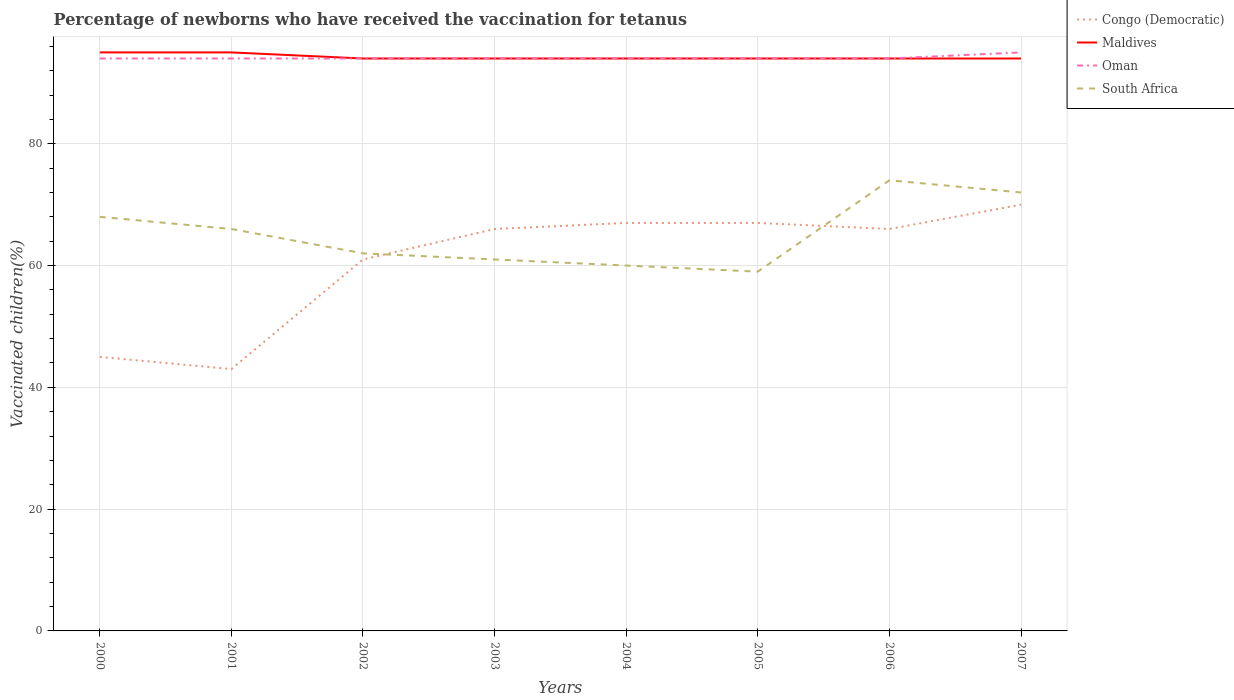How many different coloured lines are there?
Make the answer very short. 4. Is the number of lines equal to the number of legend labels?
Your answer should be compact. Yes. Across all years, what is the maximum percentage of vaccinated children in South Africa?
Ensure brevity in your answer.  59. What is the difference between the highest and the second highest percentage of vaccinated children in Maldives?
Your answer should be very brief. 1. What is the difference between the highest and the lowest percentage of vaccinated children in Oman?
Make the answer very short. 1. Does the graph contain grids?
Ensure brevity in your answer.  Yes. How are the legend labels stacked?
Give a very brief answer. Vertical. What is the title of the graph?
Make the answer very short. Percentage of newborns who have received the vaccination for tetanus. What is the label or title of the Y-axis?
Provide a succinct answer. Vaccinated children(%). What is the Vaccinated children(%) of Maldives in 2000?
Your answer should be compact. 95. What is the Vaccinated children(%) in Oman in 2000?
Your answer should be very brief. 94. What is the Vaccinated children(%) of South Africa in 2000?
Provide a succinct answer. 68. What is the Vaccinated children(%) of Oman in 2001?
Ensure brevity in your answer.  94. What is the Vaccinated children(%) in Congo (Democratic) in 2002?
Your response must be concise. 61. What is the Vaccinated children(%) of Maldives in 2002?
Ensure brevity in your answer.  94. What is the Vaccinated children(%) in Oman in 2002?
Ensure brevity in your answer.  94. What is the Vaccinated children(%) of South Africa in 2002?
Provide a succinct answer. 62. What is the Vaccinated children(%) in Maldives in 2003?
Provide a short and direct response. 94. What is the Vaccinated children(%) of Oman in 2003?
Make the answer very short. 94. What is the Vaccinated children(%) of Congo (Democratic) in 2004?
Provide a short and direct response. 67. What is the Vaccinated children(%) in Maldives in 2004?
Offer a very short reply. 94. What is the Vaccinated children(%) of Oman in 2004?
Offer a terse response. 94. What is the Vaccinated children(%) in South Africa in 2004?
Provide a short and direct response. 60. What is the Vaccinated children(%) of Maldives in 2005?
Your answer should be very brief. 94. What is the Vaccinated children(%) of Oman in 2005?
Your response must be concise. 94. What is the Vaccinated children(%) of South Africa in 2005?
Offer a terse response. 59. What is the Vaccinated children(%) in Congo (Democratic) in 2006?
Your response must be concise. 66. What is the Vaccinated children(%) of Maldives in 2006?
Offer a very short reply. 94. What is the Vaccinated children(%) of Oman in 2006?
Provide a short and direct response. 94. What is the Vaccinated children(%) in South Africa in 2006?
Your response must be concise. 74. What is the Vaccinated children(%) of Maldives in 2007?
Your answer should be very brief. 94. What is the Vaccinated children(%) in Oman in 2007?
Offer a terse response. 95. Across all years, what is the maximum Vaccinated children(%) in Maldives?
Offer a very short reply. 95. Across all years, what is the maximum Vaccinated children(%) of Oman?
Your response must be concise. 95. Across all years, what is the minimum Vaccinated children(%) in Congo (Democratic)?
Offer a very short reply. 43. Across all years, what is the minimum Vaccinated children(%) in Maldives?
Your answer should be very brief. 94. Across all years, what is the minimum Vaccinated children(%) of Oman?
Offer a terse response. 94. Across all years, what is the minimum Vaccinated children(%) of South Africa?
Provide a short and direct response. 59. What is the total Vaccinated children(%) in Congo (Democratic) in the graph?
Make the answer very short. 485. What is the total Vaccinated children(%) in Maldives in the graph?
Your answer should be compact. 754. What is the total Vaccinated children(%) of Oman in the graph?
Offer a terse response. 753. What is the total Vaccinated children(%) of South Africa in the graph?
Keep it short and to the point. 522. What is the difference between the Vaccinated children(%) of Maldives in 2000 and that in 2001?
Keep it short and to the point. 0. What is the difference between the Vaccinated children(%) in Congo (Democratic) in 2000 and that in 2002?
Make the answer very short. -16. What is the difference between the Vaccinated children(%) in Oman in 2000 and that in 2002?
Offer a very short reply. 0. What is the difference between the Vaccinated children(%) of Congo (Democratic) in 2000 and that in 2003?
Ensure brevity in your answer.  -21. What is the difference between the Vaccinated children(%) of South Africa in 2000 and that in 2003?
Your answer should be compact. 7. What is the difference between the Vaccinated children(%) in Congo (Democratic) in 2000 and that in 2004?
Provide a succinct answer. -22. What is the difference between the Vaccinated children(%) in Congo (Democratic) in 2000 and that in 2005?
Your answer should be compact. -22. What is the difference between the Vaccinated children(%) of Maldives in 2000 and that in 2005?
Your answer should be compact. 1. What is the difference between the Vaccinated children(%) of South Africa in 2000 and that in 2005?
Offer a terse response. 9. What is the difference between the Vaccinated children(%) of Congo (Democratic) in 2000 and that in 2006?
Offer a terse response. -21. What is the difference between the Vaccinated children(%) of Maldives in 2000 and that in 2006?
Keep it short and to the point. 1. What is the difference between the Vaccinated children(%) in Oman in 2000 and that in 2006?
Ensure brevity in your answer.  0. What is the difference between the Vaccinated children(%) in South Africa in 2000 and that in 2006?
Offer a terse response. -6. What is the difference between the Vaccinated children(%) of Congo (Democratic) in 2001 and that in 2002?
Ensure brevity in your answer.  -18. What is the difference between the Vaccinated children(%) in South Africa in 2001 and that in 2002?
Your response must be concise. 4. What is the difference between the Vaccinated children(%) in Maldives in 2001 and that in 2003?
Offer a terse response. 1. What is the difference between the Vaccinated children(%) of Oman in 2001 and that in 2003?
Your answer should be compact. 0. What is the difference between the Vaccinated children(%) in Congo (Democratic) in 2001 and that in 2004?
Make the answer very short. -24. What is the difference between the Vaccinated children(%) in South Africa in 2001 and that in 2004?
Offer a very short reply. 6. What is the difference between the Vaccinated children(%) in Oman in 2001 and that in 2005?
Give a very brief answer. 0. What is the difference between the Vaccinated children(%) in South Africa in 2001 and that in 2005?
Keep it short and to the point. 7. What is the difference between the Vaccinated children(%) in Oman in 2001 and that in 2006?
Ensure brevity in your answer.  0. What is the difference between the Vaccinated children(%) in Congo (Democratic) in 2001 and that in 2007?
Keep it short and to the point. -27. What is the difference between the Vaccinated children(%) of Maldives in 2001 and that in 2007?
Provide a short and direct response. 1. What is the difference between the Vaccinated children(%) in South Africa in 2001 and that in 2007?
Provide a short and direct response. -6. What is the difference between the Vaccinated children(%) of Congo (Democratic) in 2002 and that in 2004?
Provide a succinct answer. -6. What is the difference between the Vaccinated children(%) of Maldives in 2002 and that in 2004?
Give a very brief answer. 0. What is the difference between the Vaccinated children(%) of Oman in 2002 and that in 2004?
Offer a terse response. 0. What is the difference between the Vaccinated children(%) of South Africa in 2002 and that in 2004?
Make the answer very short. 2. What is the difference between the Vaccinated children(%) of Oman in 2002 and that in 2005?
Your response must be concise. 0. What is the difference between the Vaccinated children(%) of South Africa in 2002 and that in 2006?
Your response must be concise. -12. What is the difference between the Vaccinated children(%) of Maldives in 2002 and that in 2007?
Ensure brevity in your answer.  0. What is the difference between the Vaccinated children(%) of Oman in 2002 and that in 2007?
Provide a succinct answer. -1. What is the difference between the Vaccinated children(%) of South Africa in 2002 and that in 2007?
Provide a succinct answer. -10. What is the difference between the Vaccinated children(%) of Congo (Democratic) in 2003 and that in 2004?
Provide a short and direct response. -1. What is the difference between the Vaccinated children(%) in Maldives in 2003 and that in 2004?
Offer a terse response. 0. What is the difference between the Vaccinated children(%) of Oman in 2003 and that in 2004?
Provide a succinct answer. 0. What is the difference between the Vaccinated children(%) of South Africa in 2003 and that in 2004?
Offer a terse response. 1. What is the difference between the Vaccinated children(%) of Congo (Democratic) in 2003 and that in 2007?
Give a very brief answer. -4. What is the difference between the Vaccinated children(%) in Oman in 2003 and that in 2007?
Your response must be concise. -1. What is the difference between the Vaccinated children(%) of South Africa in 2003 and that in 2007?
Ensure brevity in your answer.  -11. What is the difference between the Vaccinated children(%) of Oman in 2004 and that in 2005?
Your answer should be compact. 0. What is the difference between the Vaccinated children(%) of South Africa in 2004 and that in 2006?
Provide a short and direct response. -14. What is the difference between the Vaccinated children(%) in Congo (Democratic) in 2004 and that in 2007?
Offer a very short reply. -3. What is the difference between the Vaccinated children(%) of Maldives in 2004 and that in 2007?
Offer a very short reply. 0. What is the difference between the Vaccinated children(%) in Oman in 2004 and that in 2007?
Ensure brevity in your answer.  -1. What is the difference between the Vaccinated children(%) of Congo (Democratic) in 2005 and that in 2006?
Make the answer very short. 1. What is the difference between the Vaccinated children(%) in Maldives in 2005 and that in 2006?
Your answer should be very brief. 0. What is the difference between the Vaccinated children(%) of Congo (Democratic) in 2005 and that in 2007?
Give a very brief answer. -3. What is the difference between the Vaccinated children(%) of Maldives in 2005 and that in 2007?
Provide a succinct answer. 0. What is the difference between the Vaccinated children(%) of Oman in 2005 and that in 2007?
Ensure brevity in your answer.  -1. What is the difference between the Vaccinated children(%) of Maldives in 2006 and that in 2007?
Offer a very short reply. 0. What is the difference between the Vaccinated children(%) in Oman in 2006 and that in 2007?
Provide a short and direct response. -1. What is the difference between the Vaccinated children(%) of South Africa in 2006 and that in 2007?
Provide a succinct answer. 2. What is the difference between the Vaccinated children(%) in Congo (Democratic) in 2000 and the Vaccinated children(%) in Oman in 2001?
Your answer should be compact. -49. What is the difference between the Vaccinated children(%) in Maldives in 2000 and the Vaccinated children(%) in Oman in 2001?
Keep it short and to the point. 1. What is the difference between the Vaccinated children(%) of Congo (Democratic) in 2000 and the Vaccinated children(%) of Maldives in 2002?
Offer a very short reply. -49. What is the difference between the Vaccinated children(%) of Congo (Democratic) in 2000 and the Vaccinated children(%) of Oman in 2002?
Provide a short and direct response. -49. What is the difference between the Vaccinated children(%) in Maldives in 2000 and the Vaccinated children(%) in Oman in 2002?
Your response must be concise. 1. What is the difference between the Vaccinated children(%) of Congo (Democratic) in 2000 and the Vaccinated children(%) of Maldives in 2003?
Offer a terse response. -49. What is the difference between the Vaccinated children(%) in Congo (Democratic) in 2000 and the Vaccinated children(%) in Oman in 2003?
Provide a short and direct response. -49. What is the difference between the Vaccinated children(%) of Congo (Democratic) in 2000 and the Vaccinated children(%) of South Africa in 2003?
Offer a very short reply. -16. What is the difference between the Vaccinated children(%) in Maldives in 2000 and the Vaccinated children(%) in Oman in 2003?
Ensure brevity in your answer.  1. What is the difference between the Vaccinated children(%) of Maldives in 2000 and the Vaccinated children(%) of South Africa in 2003?
Make the answer very short. 34. What is the difference between the Vaccinated children(%) of Congo (Democratic) in 2000 and the Vaccinated children(%) of Maldives in 2004?
Keep it short and to the point. -49. What is the difference between the Vaccinated children(%) in Congo (Democratic) in 2000 and the Vaccinated children(%) in Oman in 2004?
Keep it short and to the point. -49. What is the difference between the Vaccinated children(%) of Maldives in 2000 and the Vaccinated children(%) of Oman in 2004?
Offer a very short reply. 1. What is the difference between the Vaccinated children(%) of Maldives in 2000 and the Vaccinated children(%) of South Africa in 2004?
Provide a succinct answer. 35. What is the difference between the Vaccinated children(%) of Oman in 2000 and the Vaccinated children(%) of South Africa in 2004?
Your answer should be compact. 34. What is the difference between the Vaccinated children(%) of Congo (Democratic) in 2000 and the Vaccinated children(%) of Maldives in 2005?
Offer a very short reply. -49. What is the difference between the Vaccinated children(%) in Congo (Democratic) in 2000 and the Vaccinated children(%) in Oman in 2005?
Your answer should be compact. -49. What is the difference between the Vaccinated children(%) in Congo (Democratic) in 2000 and the Vaccinated children(%) in South Africa in 2005?
Your answer should be very brief. -14. What is the difference between the Vaccinated children(%) in Maldives in 2000 and the Vaccinated children(%) in South Africa in 2005?
Provide a short and direct response. 36. What is the difference between the Vaccinated children(%) of Oman in 2000 and the Vaccinated children(%) of South Africa in 2005?
Offer a terse response. 35. What is the difference between the Vaccinated children(%) of Congo (Democratic) in 2000 and the Vaccinated children(%) of Maldives in 2006?
Make the answer very short. -49. What is the difference between the Vaccinated children(%) of Congo (Democratic) in 2000 and the Vaccinated children(%) of Oman in 2006?
Provide a short and direct response. -49. What is the difference between the Vaccinated children(%) in Oman in 2000 and the Vaccinated children(%) in South Africa in 2006?
Offer a very short reply. 20. What is the difference between the Vaccinated children(%) of Congo (Democratic) in 2000 and the Vaccinated children(%) of Maldives in 2007?
Your response must be concise. -49. What is the difference between the Vaccinated children(%) of Congo (Democratic) in 2000 and the Vaccinated children(%) of Oman in 2007?
Ensure brevity in your answer.  -50. What is the difference between the Vaccinated children(%) in Congo (Democratic) in 2000 and the Vaccinated children(%) in South Africa in 2007?
Offer a terse response. -27. What is the difference between the Vaccinated children(%) of Maldives in 2000 and the Vaccinated children(%) of South Africa in 2007?
Make the answer very short. 23. What is the difference between the Vaccinated children(%) of Oman in 2000 and the Vaccinated children(%) of South Africa in 2007?
Your response must be concise. 22. What is the difference between the Vaccinated children(%) in Congo (Democratic) in 2001 and the Vaccinated children(%) in Maldives in 2002?
Provide a succinct answer. -51. What is the difference between the Vaccinated children(%) of Congo (Democratic) in 2001 and the Vaccinated children(%) of Oman in 2002?
Provide a succinct answer. -51. What is the difference between the Vaccinated children(%) of Congo (Democratic) in 2001 and the Vaccinated children(%) of Maldives in 2003?
Provide a short and direct response. -51. What is the difference between the Vaccinated children(%) of Congo (Democratic) in 2001 and the Vaccinated children(%) of Oman in 2003?
Give a very brief answer. -51. What is the difference between the Vaccinated children(%) in Congo (Democratic) in 2001 and the Vaccinated children(%) in South Africa in 2003?
Offer a very short reply. -18. What is the difference between the Vaccinated children(%) in Maldives in 2001 and the Vaccinated children(%) in Oman in 2003?
Your answer should be compact. 1. What is the difference between the Vaccinated children(%) in Congo (Democratic) in 2001 and the Vaccinated children(%) in Maldives in 2004?
Make the answer very short. -51. What is the difference between the Vaccinated children(%) in Congo (Democratic) in 2001 and the Vaccinated children(%) in Oman in 2004?
Keep it short and to the point. -51. What is the difference between the Vaccinated children(%) of Congo (Democratic) in 2001 and the Vaccinated children(%) of South Africa in 2004?
Ensure brevity in your answer.  -17. What is the difference between the Vaccinated children(%) of Maldives in 2001 and the Vaccinated children(%) of Oman in 2004?
Provide a short and direct response. 1. What is the difference between the Vaccinated children(%) of Oman in 2001 and the Vaccinated children(%) of South Africa in 2004?
Keep it short and to the point. 34. What is the difference between the Vaccinated children(%) of Congo (Democratic) in 2001 and the Vaccinated children(%) of Maldives in 2005?
Your answer should be very brief. -51. What is the difference between the Vaccinated children(%) in Congo (Democratic) in 2001 and the Vaccinated children(%) in Oman in 2005?
Your response must be concise. -51. What is the difference between the Vaccinated children(%) of Congo (Democratic) in 2001 and the Vaccinated children(%) of South Africa in 2005?
Your response must be concise. -16. What is the difference between the Vaccinated children(%) of Oman in 2001 and the Vaccinated children(%) of South Africa in 2005?
Your answer should be compact. 35. What is the difference between the Vaccinated children(%) in Congo (Democratic) in 2001 and the Vaccinated children(%) in Maldives in 2006?
Ensure brevity in your answer.  -51. What is the difference between the Vaccinated children(%) in Congo (Democratic) in 2001 and the Vaccinated children(%) in Oman in 2006?
Provide a succinct answer. -51. What is the difference between the Vaccinated children(%) in Congo (Democratic) in 2001 and the Vaccinated children(%) in South Africa in 2006?
Your answer should be compact. -31. What is the difference between the Vaccinated children(%) in Maldives in 2001 and the Vaccinated children(%) in South Africa in 2006?
Give a very brief answer. 21. What is the difference between the Vaccinated children(%) in Congo (Democratic) in 2001 and the Vaccinated children(%) in Maldives in 2007?
Ensure brevity in your answer.  -51. What is the difference between the Vaccinated children(%) of Congo (Democratic) in 2001 and the Vaccinated children(%) of Oman in 2007?
Offer a terse response. -52. What is the difference between the Vaccinated children(%) in Maldives in 2001 and the Vaccinated children(%) in Oman in 2007?
Make the answer very short. 0. What is the difference between the Vaccinated children(%) in Maldives in 2001 and the Vaccinated children(%) in South Africa in 2007?
Give a very brief answer. 23. What is the difference between the Vaccinated children(%) of Congo (Democratic) in 2002 and the Vaccinated children(%) of Maldives in 2003?
Keep it short and to the point. -33. What is the difference between the Vaccinated children(%) in Congo (Democratic) in 2002 and the Vaccinated children(%) in Oman in 2003?
Keep it short and to the point. -33. What is the difference between the Vaccinated children(%) of Maldives in 2002 and the Vaccinated children(%) of Oman in 2003?
Provide a succinct answer. 0. What is the difference between the Vaccinated children(%) in Oman in 2002 and the Vaccinated children(%) in South Africa in 2003?
Offer a terse response. 33. What is the difference between the Vaccinated children(%) of Congo (Democratic) in 2002 and the Vaccinated children(%) of Maldives in 2004?
Keep it short and to the point. -33. What is the difference between the Vaccinated children(%) in Congo (Democratic) in 2002 and the Vaccinated children(%) in Oman in 2004?
Your response must be concise. -33. What is the difference between the Vaccinated children(%) in Congo (Democratic) in 2002 and the Vaccinated children(%) in South Africa in 2004?
Make the answer very short. 1. What is the difference between the Vaccinated children(%) of Maldives in 2002 and the Vaccinated children(%) of Oman in 2004?
Make the answer very short. 0. What is the difference between the Vaccinated children(%) in Congo (Democratic) in 2002 and the Vaccinated children(%) in Maldives in 2005?
Your answer should be compact. -33. What is the difference between the Vaccinated children(%) in Congo (Democratic) in 2002 and the Vaccinated children(%) in Oman in 2005?
Offer a very short reply. -33. What is the difference between the Vaccinated children(%) in Maldives in 2002 and the Vaccinated children(%) in Oman in 2005?
Give a very brief answer. 0. What is the difference between the Vaccinated children(%) of Maldives in 2002 and the Vaccinated children(%) of South Africa in 2005?
Provide a succinct answer. 35. What is the difference between the Vaccinated children(%) of Oman in 2002 and the Vaccinated children(%) of South Africa in 2005?
Your response must be concise. 35. What is the difference between the Vaccinated children(%) in Congo (Democratic) in 2002 and the Vaccinated children(%) in Maldives in 2006?
Provide a short and direct response. -33. What is the difference between the Vaccinated children(%) of Congo (Democratic) in 2002 and the Vaccinated children(%) of Oman in 2006?
Ensure brevity in your answer.  -33. What is the difference between the Vaccinated children(%) in Congo (Democratic) in 2002 and the Vaccinated children(%) in South Africa in 2006?
Offer a very short reply. -13. What is the difference between the Vaccinated children(%) in Maldives in 2002 and the Vaccinated children(%) in South Africa in 2006?
Your response must be concise. 20. What is the difference between the Vaccinated children(%) of Congo (Democratic) in 2002 and the Vaccinated children(%) of Maldives in 2007?
Offer a very short reply. -33. What is the difference between the Vaccinated children(%) in Congo (Democratic) in 2002 and the Vaccinated children(%) in Oman in 2007?
Offer a very short reply. -34. What is the difference between the Vaccinated children(%) of Maldives in 2002 and the Vaccinated children(%) of Oman in 2007?
Give a very brief answer. -1. What is the difference between the Vaccinated children(%) of Maldives in 2002 and the Vaccinated children(%) of South Africa in 2007?
Offer a terse response. 22. What is the difference between the Vaccinated children(%) of Oman in 2003 and the Vaccinated children(%) of South Africa in 2004?
Offer a very short reply. 34. What is the difference between the Vaccinated children(%) in Maldives in 2003 and the Vaccinated children(%) in Oman in 2005?
Keep it short and to the point. 0. What is the difference between the Vaccinated children(%) in Maldives in 2003 and the Vaccinated children(%) in South Africa in 2005?
Your answer should be compact. 35. What is the difference between the Vaccinated children(%) of Oman in 2003 and the Vaccinated children(%) of South Africa in 2005?
Make the answer very short. 35. What is the difference between the Vaccinated children(%) of Congo (Democratic) in 2003 and the Vaccinated children(%) of Oman in 2006?
Provide a succinct answer. -28. What is the difference between the Vaccinated children(%) of Maldives in 2003 and the Vaccinated children(%) of Oman in 2006?
Provide a succinct answer. 0. What is the difference between the Vaccinated children(%) of Maldives in 2003 and the Vaccinated children(%) of South Africa in 2006?
Give a very brief answer. 20. What is the difference between the Vaccinated children(%) of Oman in 2003 and the Vaccinated children(%) of South Africa in 2006?
Keep it short and to the point. 20. What is the difference between the Vaccinated children(%) in Congo (Democratic) in 2004 and the Vaccinated children(%) in Maldives in 2005?
Offer a very short reply. -27. What is the difference between the Vaccinated children(%) of Congo (Democratic) in 2004 and the Vaccinated children(%) of Oman in 2005?
Keep it short and to the point. -27. What is the difference between the Vaccinated children(%) in Congo (Democratic) in 2004 and the Vaccinated children(%) in South Africa in 2005?
Make the answer very short. 8. What is the difference between the Vaccinated children(%) of Maldives in 2004 and the Vaccinated children(%) of Oman in 2005?
Provide a short and direct response. 0. What is the difference between the Vaccinated children(%) in Oman in 2004 and the Vaccinated children(%) in South Africa in 2005?
Keep it short and to the point. 35. What is the difference between the Vaccinated children(%) in Congo (Democratic) in 2004 and the Vaccinated children(%) in Maldives in 2006?
Provide a short and direct response. -27. What is the difference between the Vaccinated children(%) of Maldives in 2004 and the Vaccinated children(%) of Oman in 2006?
Your response must be concise. 0. What is the difference between the Vaccinated children(%) in Maldives in 2004 and the Vaccinated children(%) in South Africa in 2006?
Keep it short and to the point. 20. What is the difference between the Vaccinated children(%) of Oman in 2004 and the Vaccinated children(%) of South Africa in 2006?
Your answer should be compact. 20. What is the difference between the Vaccinated children(%) in Congo (Democratic) in 2004 and the Vaccinated children(%) in Maldives in 2007?
Offer a terse response. -27. What is the difference between the Vaccinated children(%) in Congo (Democratic) in 2004 and the Vaccinated children(%) in South Africa in 2007?
Offer a terse response. -5. What is the difference between the Vaccinated children(%) of Maldives in 2004 and the Vaccinated children(%) of Oman in 2007?
Your response must be concise. -1. What is the difference between the Vaccinated children(%) of Maldives in 2004 and the Vaccinated children(%) of South Africa in 2007?
Offer a terse response. 22. What is the difference between the Vaccinated children(%) of Maldives in 2005 and the Vaccinated children(%) of Oman in 2006?
Give a very brief answer. 0. What is the difference between the Vaccinated children(%) in Congo (Democratic) in 2005 and the Vaccinated children(%) in Oman in 2007?
Your response must be concise. -28. What is the difference between the Vaccinated children(%) of Congo (Democratic) in 2005 and the Vaccinated children(%) of South Africa in 2007?
Keep it short and to the point. -5. What is the difference between the Vaccinated children(%) in Maldives in 2005 and the Vaccinated children(%) in South Africa in 2007?
Your answer should be compact. 22. What is the difference between the Vaccinated children(%) in Oman in 2005 and the Vaccinated children(%) in South Africa in 2007?
Give a very brief answer. 22. What is the difference between the Vaccinated children(%) in Congo (Democratic) in 2006 and the Vaccinated children(%) in Oman in 2007?
Your answer should be compact. -29. What is the difference between the Vaccinated children(%) of Congo (Democratic) in 2006 and the Vaccinated children(%) of South Africa in 2007?
Keep it short and to the point. -6. What is the difference between the Vaccinated children(%) in Maldives in 2006 and the Vaccinated children(%) in South Africa in 2007?
Provide a succinct answer. 22. What is the difference between the Vaccinated children(%) of Oman in 2006 and the Vaccinated children(%) of South Africa in 2007?
Keep it short and to the point. 22. What is the average Vaccinated children(%) in Congo (Democratic) per year?
Give a very brief answer. 60.62. What is the average Vaccinated children(%) of Maldives per year?
Keep it short and to the point. 94.25. What is the average Vaccinated children(%) in Oman per year?
Make the answer very short. 94.12. What is the average Vaccinated children(%) of South Africa per year?
Your answer should be very brief. 65.25. In the year 2000, what is the difference between the Vaccinated children(%) in Congo (Democratic) and Vaccinated children(%) in Oman?
Give a very brief answer. -49. In the year 2000, what is the difference between the Vaccinated children(%) in Congo (Democratic) and Vaccinated children(%) in South Africa?
Ensure brevity in your answer.  -23. In the year 2000, what is the difference between the Vaccinated children(%) of Maldives and Vaccinated children(%) of South Africa?
Offer a very short reply. 27. In the year 2001, what is the difference between the Vaccinated children(%) in Congo (Democratic) and Vaccinated children(%) in Maldives?
Offer a very short reply. -52. In the year 2001, what is the difference between the Vaccinated children(%) of Congo (Democratic) and Vaccinated children(%) of Oman?
Offer a very short reply. -51. In the year 2001, what is the difference between the Vaccinated children(%) of Maldives and Vaccinated children(%) of Oman?
Provide a succinct answer. 1. In the year 2002, what is the difference between the Vaccinated children(%) in Congo (Democratic) and Vaccinated children(%) in Maldives?
Your answer should be very brief. -33. In the year 2002, what is the difference between the Vaccinated children(%) in Congo (Democratic) and Vaccinated children(%) in Oman?
Give a very brief answer. -33. In the year 2002, what is the difference between the Vaccinated children(%) of Maldives and Vaccinated children(%) of Oman?
Offer a terse response. 0. In the year 2003, what is the difference between the Vaccinated children(%) of Congo (Democratic) and Vaccinated children(%) of Oman?
Your answer should be very brief. -28. In the year 2003, what is the difference between the Vaccinated children(%) in Maldives and Vaccinated children(%) in Oman?
Provide a succinct answer. 0. In the year 2003, what is the difference between the Vaccinated children(%) of Maldives and Vaccinated children(%) of South Africa?
Offer a very short reply. 33. In the year 2003, what is the difference between the Vaccinated children(%) in Oman and Vaccinated children(%) in South Africa?
Offer a terse response. 33. In the year 2004, what is the difference between the Vaccinated children(%) in Congo (Democratic) and Vaccinated children(%) in South Africa?
Provide a short and direct response. 7. In the year 2004, what is the difference between the Vaccinated children(%) in Maldives and Vaccinated children(%) in South Africa?
Offer a very short reply. 34. In the year 2005, what is the difference between the Vaccinated children(%) of Congo (Democratic) and Vaccinated children(%) of Oman?
Provide a succinct answer. -27. In the year 2005, what is the difference between the Vaccinated children(%) of Congo (Democratic) and Vaccinated children(%) of South Africa?
Provide a succinct answer. 8. In the year 2005, what is the difference between the Vaccinated children(%) of Maldives and Vaccinated children(%) of South Africa?
Your response must be concise. 35. In the year 2006, what is the difference between the Vaccinated children(%) of Congo (Democratic) and Vaccinated children(%) of Maldives?
Provide a short and direct response. -28. In the year 2006, what is the difference between the Vaccinated children(%) of Congo (Democratic) and Vaccinated children(%) of Oman?
Your answer should be very brief. -28. In the year 2006, what is the difference between the Vaccinated children(%) in Congo (Democratic) and Vaccinated children(%) in South Africa?
Your answer should be compact. -8. In the year 2006, what is the difference between the Vaccinated children(%) of Maldives and Vaccinated children(%) of Oman?
Your response must be concise. 0. In the year 2006, what is the difference between the Vaccinated children(%) in Oman and Vaccinated children(%) in South Africa?
Offer a terse response. 20. In the year 2007, what is the difference between the Vaccinated children(%) in Maldives and Vaccinated children(%) in South Africa?
Keep it short and to the point. 22. What is the ratio of the Vaccinated children(%) of Congo (Democratic) in 2000 to that in 2001?
Give a very brief answer. 1.05. What is the ratio of the Vaccinated children(%) of South Africa in 2000 to that in 2001?
Provide a short and direct response. 1.03. What is the ratio of the Vaccinated children(%) of Congo (Democratic) in 2000 to that in 2002?
Your answer should be very brief. 0.74. What is the ratio of the Vaccinated children(%) of Maldives in 2000 to that in 2002?
Keep it short and to the point. 1.01. What is the ratio of the Vaccinated children(%) in Oman in 2000 to that in 2002?
Ensure brevity in your answer.  1. What is the ratio of the Vaccinated children(%) of South Africa in 2000 to that in 2002?
Ensure brevity in your answer.  1.1. What is the ratio of the Vaccinated children(%) of Congo (Democratic) in 2000 to that in 2003?
Make the answer very short. 0.68. What is the ratio of the Vaccinated children(%) of Maldives in 2000 to that in 2003?
Offer a very short reply. 1.01. What is the ratio of the Vaccinated children(%) of Oman in 2000 to that in 2003?
Your response must be concise. 1. What is the ratio of the Vaccinated children(%) in South Africa in 2000 to that in 2003?
Provide a short and direct response. 1.11. What is the ratio of the Vaccinated children(%) of Congo (Democratic) in 2000 to that in 2004?
Your answer should be very brief. 0.67. What is the ratio of the Vaccinated children(%) of Maldives in 2000 to that in 2004?
Provide a succinct answer. 1.01. What is the ratio of the Vaccinated children(%) of South Africa in 2000 to that in 2004?
Make the answer very short. 1.13. What is the ratio of the Vaccinated children(%) in Congo (Democratic) in 2000 to that in 2005?
Keep it short and to the point. 0.67. What is the ratio of the Vaccinated children(%) of Maldives in 2000 to that in 2005?
Keep it short and to the point. 1.01. What is the ratio of the Vaccinated children(%) of Oman in 2000 to that in 2005?
Your answer should be compact. 1. What is the ratio of the Vaccinated children(%) of South Africa in 2000 to that in 2005?
Your response must be concise. 1.15. What is the ratio of the Vaccinated children(%) in Congo (Democratic) in 2000 to that in 2006?
Offer a very short reply. 0.68. What is the ratio of the Vaccinated children(%) of Maldives in 2000 to that in 2006?
Your response must be concise. 1.01. What is the ratio of the Vaccinated children(%) in Oman in 2000 to that in 2006?
Offer a terse response. 1. What is the ratio of the Vaccinated children(%) of South Africa in 2000 to that in 2006?
Your answer should be compact. 0.92. What is the ratio of the Vaccinated children(%) of Congo (Democratic) in 2000 to that in 2007?
Your answer should be compact. 0.64. What is the ratio of the Vaccinated children(%) of Maldives in 2000 to that in 2007?
Offer a very short reply. 1.01. What is the ratio of the Vaccinated children(%) in South Africa in 2000 to that in 2007?
Your answer should be very brief. 0.94. What is the ratio of the Vaccinated children(%) of Congo (Democratic) in 2001 to that in 2002?
Provide a short and direct response. 0.7. What is the ratio of the Vaccinated children(%) in Maldives in 2001 to that in 2002?
Give a very brief answer. 1.01. What is the ratio of the Vaccinated children(%) of South Africa in 2001 to that in 2002?
Offer a terse response. 1.06. What is the ratio of the Vaccinated children(%) in Congo (Democratic) in 2001 to that in 2003?
Your answer should be very brief. 0.65. What is the ratio of the Vaccinated children(%) of Maldives in 2001 to that in 2003?
Your answer should be very brief. 1.01. What is the ratio of the Vaccinated children(%) in South Africa in 2001 to that in 2003?
Offer a terse response. 1.08. What is the ratio of the Vaccinated children(%) in Congo (Democratic) in 2001 to that in 2004?
Your answer should be compact. 0.64. What is the ratio of the Vaccinated children(%) of Maldives in 2001 to that in 2004?
Make the answer very short. 1.01. What is the ratio of the Vaccinated children(%) in Oman in 2001 to that in 2004?
Keep it short and to the point. 1. What is the ratio of the Vaccinated children(%) of South Africa in 2001 to that in 2004?
Give a very brief answer. 1.1. What is the ratio of the Vaccinated children(%) in Congo (Democratic) in 2001 to that in 2005?
Your answer should be very brief. 0.64. What is the ratio of the Vaccinated children(%) of Maldives in 2001 to that in 2005?
Your response must be concise. 1.01. What is the ratio of the Vaccinated children(%) in Oman in 2001 to that in 2005?
Keep it short and to the point. 1. What is the ratio of the Vaccinated children(%) of South Africa in 2001 to that in 2005?
Provide a succinct answer. 1.12. What is the ratio of the Vaccinated children(%) of Congo (Democratic) in 2001 to that in 2006?
Keep it short and to the point. 0.65. What is the ratio of the Vaccinated children(%) of Maldives in 2001 to that in 2006?
Offer a terse response. 1.01. What is the ratio of the Vaccinated children(%) in Oman in 2001 to that in 2006?
Make the answer very short. 1. What is the ratio of the Vaccinated children(%) of South Africa in 2001 to that in 2006?
Your answer should be very brief. 0.89. What is the ratio of the Vaccinated children(%) of Congo (Democratic) in 2001 to that in 2007?
Your response must be concise. 0.61. What is the ratio of the Vaccinated children(%) in Maldives in 2001 to that in 2007?
Your response must be concise. 1.01. What is the ratio of the Vaccinated children(%) in Oman in 2001 to that in 2007?
Offer a terse response. 0.99. What is the ratio of the Vaccinated children(%) of South Africa in 2001 to that in 2007?
Provide a succinct answer. 0.92. What is the ratio of the Vaccinated children(%) of Congo (Democratic) in 2002 to that in 2003?
Give a very brief answer. 0.92. What is the ratio of the Vaccinated children(%) of South Africa in 2002 to that in 2003?
Make the answer very short. 1.02. What is the ratio of the Vaccinated children(%) of Congo (Democratic) in 2002 to that in 2004?
Offer a terse response. 0.91. What is the ratio of the Vaccinated children(%) in Oman in 2002 to that in 2004?
Your answer should be compact. 1. What is the ratio of the Vaccinated children(%) in Congo (Democratic) in 2002 to that in 2005?
Provide a short and direct response. 0.91. What is the ratio of the Vaccinated children(%) of South Africa in 2002 to that in 2005?
Your response must be concise. 1.05. What is the ratio of the Vaccinated children(%) of Congo (Democratic) in 2002 to that in 2006?
Provide a succinct answer. 0.92. What is the ratio of the Vaccinated children(%) in Oman in 2002 to that in 2006?
Provide a short and direct response. 1. What is the ratio of the Vaccinated children(%) of South Africa in 2002 to that in 2006?
Ensure brevity in your answer.  0.84. What is the ratio of the Vaccinated children(%) of Congo (Democratic) in 2002 to that in 2007?
Offer a very short reply. 0.87. What is the ratio of the Vaccinated children(%) of Oman in 2002 to that in 2007?
Your answer should be compact. 0.99. What is the ratio of the Vaccinated children(%) of South Africa in 2002 to that in 2007?
Give a very brief answer. 0.86. What is the ratio of the Vaccinated children(%) of Congo (Democratic) in 2003 to that in 2004?
Your answer should be compact. 0.99. What is the ratio of the Vaccinated children(%) of Maldives in 2003 to that in 2004?
Provide a succinct answer. 1. What is the ratio of the Vaccinated children(%) in Oman in 2003 to that in 2004?
Offer a terse response. 1. What is the ratio of the Vaccinated children(%) in South Africa in 2003 to that in 2004?
Provide a succinct answer. 1.02. What is the ratio of the Vaccinated children(%) of Congo (Democratic) in 2003 to that in 2005?
Your answer should be compact. 0.99. What is the ratio of the Vaccinated children(%) in South Africa in 2003 to that in 2005?
Make the answer very short. 1.03. What is the ratio of the Vaccinated children(%) of South Africa in 2003 to that in 2006?
Your answer should be very brief. 0.82. What is the ratio of the Vaccinated children(%) of Congo (Democratic) in 2003 to that in 2007?
Your answer should be very brief. 0.94. What is the ratio of the Vaccinated children(%) of Oman in 2003 to that in 2007?
Give a very brief answer. 0.99. What is the ratio of the Vaccinated children(%) of South Africa in 2003 to that in 2007?
Your answer should be compact. 0.85. What is the ratio of the Vaccinated children(%) in Oman in 2004 to that in 2005?
Provide a short and direct response. 1. What is the ratio of the Vaccinated children(%) in South Africa in 2004 to that in 2005?
Keep it short and to the point. 1.02. What is the ratio of the Vaccinated children(%) in Congo (Democratic) in 2004 to that in 2006?
Your answer should be very brief. 1.02. What is the ratio of the Vaccinated children(%) in South Africa in 2004 to that in 2006?
Your answer should be very brief. 0.81. What is the ratio of the Vaccinated children(%) of Congo (Democratic) in 2004 to that in 2007?
Your answer should be compact. 0.96. What is the ratio of the Vaccinated children(%) in Maldives in 2004 to that in 2007?
Your answer should be very brief. 1. What is the ratio of the Vaccinated children(%) in Oman in 2004 to that in 2007?
Your answer should be compact. 0.99. What is the ratio of the Vaccinated children(%) of Congo (Democratic) in 2005 to that in 2006?
Keep it short and to the point. 1.02. What is the ratio of the Vaccinated children(%) in Oman in 2005 to that in 2006?
Make the answer very short. 1. What is the ratio of the Vaccinated children(%) of South Africa in 2005 to that in 2006?
Offer a terse response. 0.8. What is the ratio of the Vaccinated children(%) in Congo (Democratic) in 2005 to that in 2007?
Keep it short and to the point. 0.96. What is the ratio of the Vaccinated children(%) of Maldives in 2005 to that in 2007?
Provide a short and direct response. 1. What is the ratio of the Vaccinated children(%) in South Africa in 2005 to that in 2007?
Give a very brief answer. 0.82. What is the ratio of the Vaccinated children(%) of Congo (Democratic) in 2006 to that in 2007?
Ensure brevity in your answer.  0.94. What is the ratio of the Vaccinated children(%) of Maldives in 2006 to that in 2007?
Your answer should be compact. 1. What is the ratio of the Vaccinated children(%) of South Africa in 2006 to that in 2007?
Your answer should be very brief. 1.03. What is the difference between the highest and the second highest Vaccinated children(%) in Congo (Democratic)?
Offer a terse response. 3. What is the difference between the highest and the second highest Vaccinated children(%) in Maldives?
Offer a terse response. 0. What is the difference between the highest and the lowest Vaccinated children(%) of Oman?
Your answer should be compact. 1. 